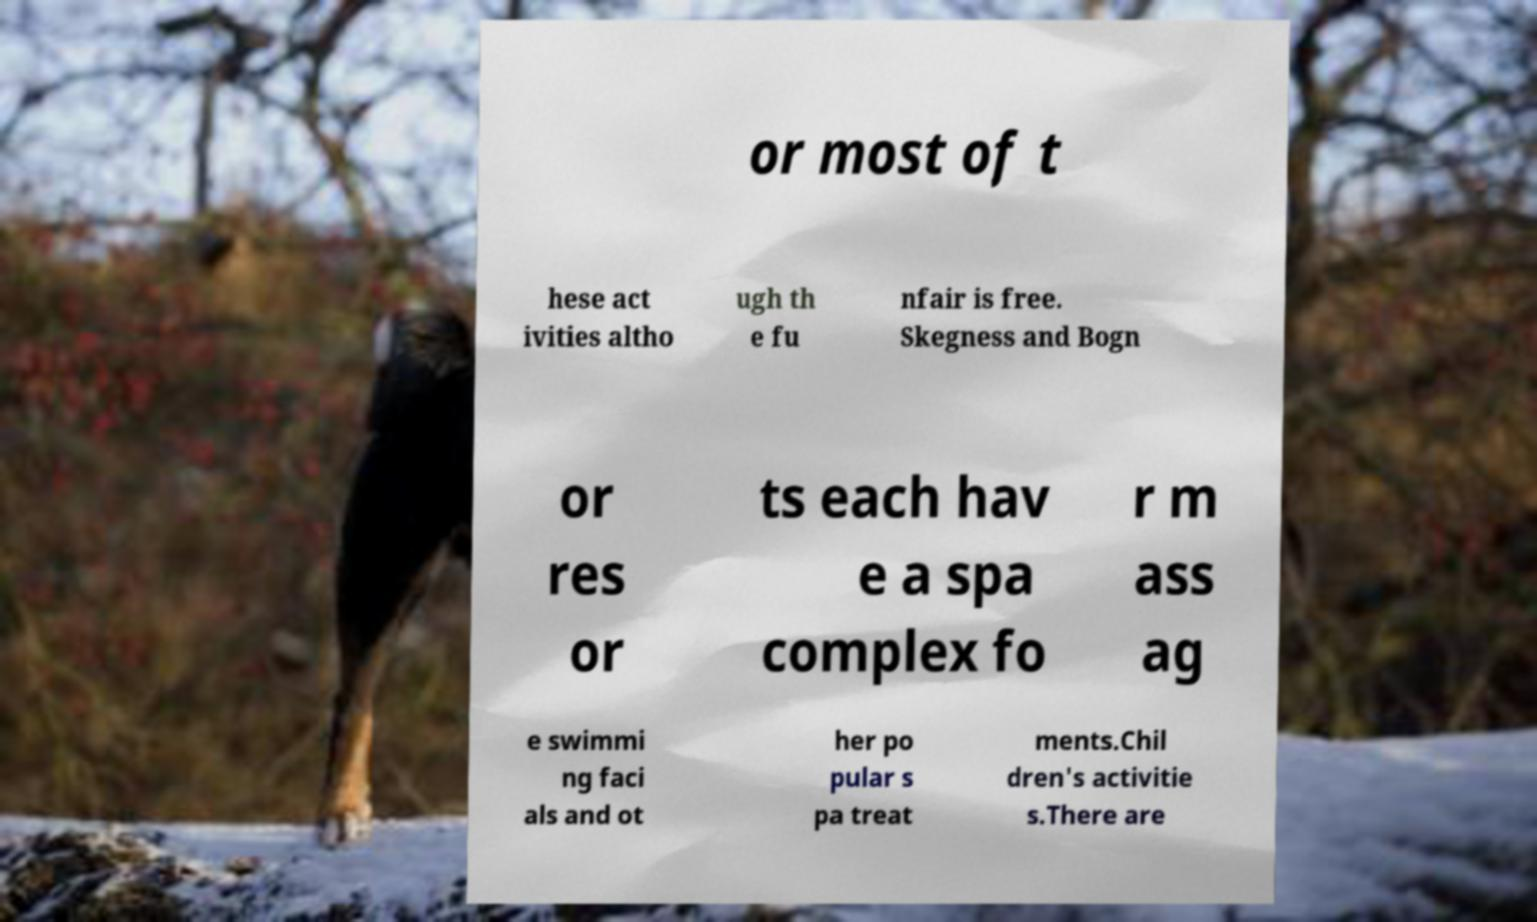Could you extract and type out the text from this image? or most of t hese act ivities altho ugh th e fu nfair is free. Skegness and Bogn or res or ts each hav e a spa complex fo r m ass ag e swimmi ng faci als and ot her po pular s pa treat ments.Chil dren's activitie s.There are 